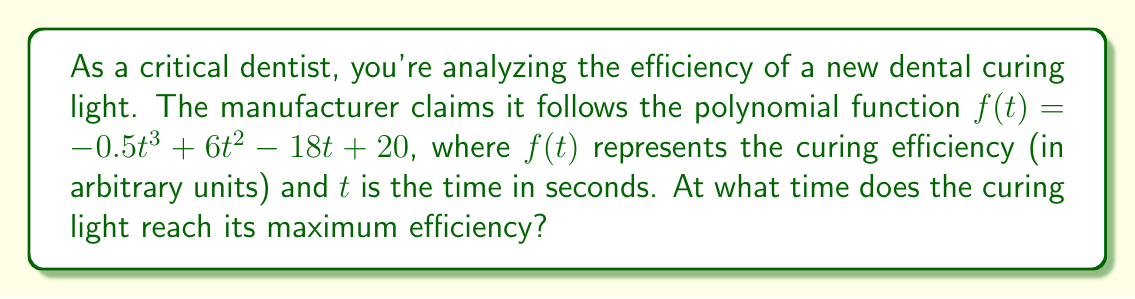Provide a solution to this math problem. To find the maximum efficiency, we need to follow these steps:

1) The maximum efficiency occurs at the peak of the polynomial curve. This point corresponds to where the derivative of the function equals zero.

2) Let's find the derivative of $f(t)$:
   $$f'(t) = -1.5t^2 + 12t - 18$$

3) Set the derivative equal to zero and solve for $t$:
   $$-1.5t^2 + 12t - 18 = 0$$

4) This is a quadratic equation. We can solve it using the quadratic formula:
   $$t = \frac{-b \pm \sqrt{b^2 - 4ac}}{2a}$$
   where $a = -1.5$, $b = 12$, and $c = -18$

5) Plugging in these values:
   $$t = \frac{-12 \pm \sqrt{12^2 - 4(-1.5)(-18)}}{2(-1.5)}$$
   $$= \frac{-12 \pm \sqrt{144 - 108}}{-3}$$
   $$= \frac{-12 \pm \sqrt{36}}{-3}$$
   $$= \frac{-12 \pm 6}{-3}$$

6) This gives us two solutions:
   $$t = \frac{-12 + 6}{-3} = 2$$ or $$t = \frac{-12 - 6}{-3} = 6$$

7) To determine which of these is the maximum (rather than the minimum), we can check the second derivative:
   $$f''(t) = -3t + 12$$

8) At $t = 2$: $f''(2) = -3(2) + 12 = 6 > 0$, indicating a minimum.
   At $t = 6$: $f''(6) = -3(6) + 12 = -6 < 0$, indicating a maximum.

Therefore, the maximum efficiency occurs at $t = 6$ seconds.
Answer: 6 seconds 